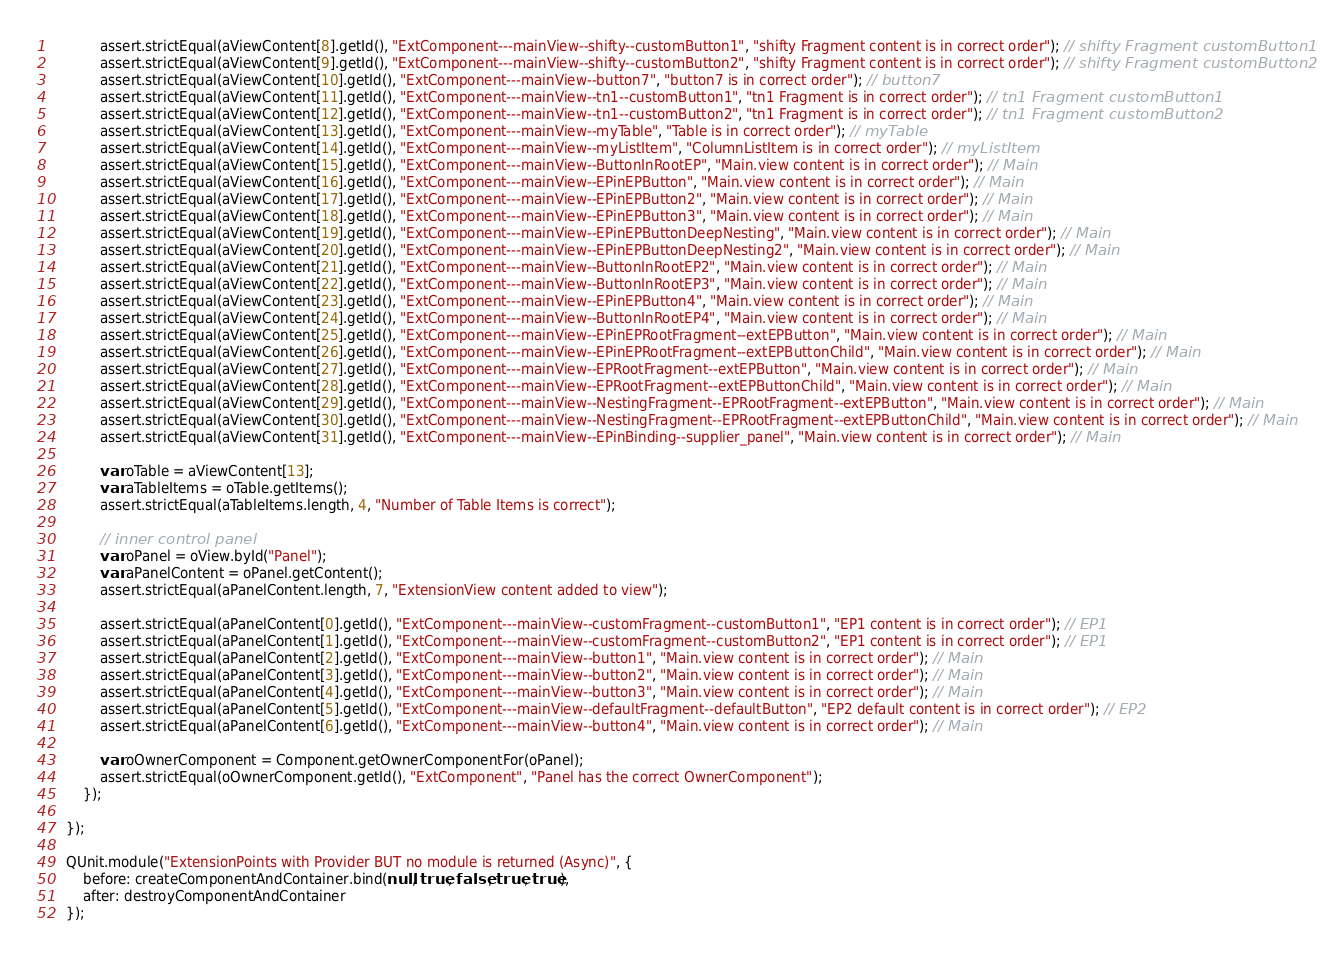<code> <loc_0><loc_0><loc_500><loc_500><_JavaScript_>			assert.strictEqual(aViewContent[8].getId(), "ExtComponent---mainView--shifty--customButton1", "shifty Fragment content is in correct order"); // shifty Fragment customButton1
			assert.strictEqual(aViewContent[9].getId(), "ExtComponent---mainView--shifty--customButton2", "shifty Fragment content is in correct order"); // shifty Fragment customButton2
			assert.strictEqual(aViewContent[10].getId(), "ExtComponent---mainView--button7", "button7 is in correct order"); // button7
			assert.strictEqual(aViewContent[11].getId(), "ExtComponent---mainView--tn1--customButton1", "tn1 Fragment is in correct order"); // tn1 Fragment customButton1
			assert.strictEqual(aViewContent[12].getId(), "ExtComponent---mainView--tn1--customButton2", "tn1 Fragment is in correct order"); // tn1 Fragment customButton2
			assert.strictEqual(aViewContent[13].getId(), "ExtComponent---mainView--myTable", "Table is in correct order"); // myTable
			assert.strictEqual(aViewContent[14].getId(), "ExtComponent---mainView--myListItem", "ColumnListItem is in correct order"); // myListItem
			assert.strictEqual(aViewContent[15].getId(), "ExtComponent---mainView--ButtonInRootEP", "Main.view content is in correct order"); // Main
			assert.strictEqual(aViewContent[16].getId(), "ExtComponent---mainView--EPinEPButton", "Main.view content is in correct order"); // Main
			assert.strictEqual(aViewContent[17].getId(), "ExtComponent---mainView--EPinEPButton2", "Main.view content is in correct order"); // Main
			assert.strictEqual(aViewContent[18].getId(), "ExtComponent---mainView--EPinEPButton3", "Main.view content is in correct order"); // Main
			assert.strictEqual(aViewContent[19].getId(), "ExtComponent---mainView--EPinEPButtonDeepNesting", "Main.view content is in correct order"); // Main
			assert.strictEqual(aViewContent[20].getId(), "ExtComponent---mainView--EPinEPButtonDeepNesting2", "Main.view content is in correct order"); // Main
			assert.strictEqual(aViewContent[21].getId(), "ExtComponent---mainView--ButtonInRootEP2", "Main.view content is in correct order"); // Main
			assert.strictEqual(aViewContent[22].getId(), "ExtComponent---mainView--ButtonInRootEP3", "Main.view content is in correct order"); // Main
			assert.strictEqual(aViewContent[23].getId(), "ExtComponent---mainView--EPinEPButton4", "Main.view content is in correct order"); // Main
			assert.strictEqual(aViewContent[24].getId(), "ExtComponent---mainView--ButtonInRootEP4", "Main.view content is in correct order"); // Main
			assert.strictEqual(aViewContent[25].getId(), "ExtComponent---mainView--EPinEPRootFragment--extEPButton", "Main.view content is in correct order"); // Main
			assert.strictEqual(aViewContent[26].getId(), "ExtComponent---mainView--EPinEPRootFragment--extEPButtonChild", "Main.view content is in correct order"); // Main
			assert.strictEqual(aViewContent[27].getId(), "ExtComponent---mainView--EPRootFragment--extEPButton", "Main.view content is in correct order"); // Main
			assert.strictEqual(aViewContent[28].getId(), "ExtComponent---mainView--EPRootFragment--extEPButtonChild", "Main.view content is in correct order"); // Main
			assert.strictEqual(aViewContent[29].getId(), "ExtComponent---mainView--NestingFragment--EPRootFragment--extEPButton", "Main.view content is in correct order"); // Main
			assert.strictEqual(aViewContent[30].getId(), "ExtComponent---mainView--NestingFragment--EPRootFragment--extEPButtonChild", "Main.view content is in correct order"); // Main
			assert.strictEqual(aViewContent[31].getId(), "ExtComponent---mainView--EPinBinding--supplier_panel", "Main.view content is in correct order"); // Main

			var oTable = aViewContent[13];
			var aTableItems = oTable.getItems();
			assert.strictEqual(aTableItems.length, 4, "Number of Table Items is correct");

			// inner control panel
			var oPanel = oView.byId("Panel");
			var aPanelContent = oPanel.getContent();
			assert.strictEqual(aPanelContent.length, 7, "ExtensionView content added to view");

			assert.strictEqual(aPanelContent[0].getId(), "ExtComponent---mainView--customFragment--customButton1", "EP1 content is in correct order"); // EP1
			assert.strictEqual(aPanelContent[1].getId(), "ExtComponent---mainView--customFragment--customButton2", "EP1 content is in correct order"); // EP1
			assert.strictEqual(aPanelContent[2].getId(), "ExtComponent---mainView--button1", "Main.view content is in correct order"); // Main
			assert.strictEqual(aPanelContent[3].getId(), "ExtComponent---mainView--button2", "Main.view content is in correct order"); // Main
			assert.strictEqual(aPanelContent[4].getId(), "ExtComponent---mainView--button3", "Main.view content is in correct order"); // Main
			assert.strictEqual(aPanelContent[5].getId(), "ExtComponent---mainView--defaultFragment--defaultButton", "EP2 default content is in correct order"); // EP2
			assert.strictEqual(aPanelContent[6].getId(), "ExtComponent---mainView--button4", "Main.view content is in correct order"); // Main

			var oOwnerComponent = Component.getOwnerComponentFor(oPanel);
			assert.strictEqual(oOwnerComponent.getId(), "ExtComponent", "Panel has the correct OwnerComponent");
		});

	});

	QUnit.module("ExtensionPoints with Provider BUT no module is returned (Async)", {
		before: createComponentAndContainer.bind(null, true, false, true, true),
		after: destroyComponentAndContainer
	});
</code> 